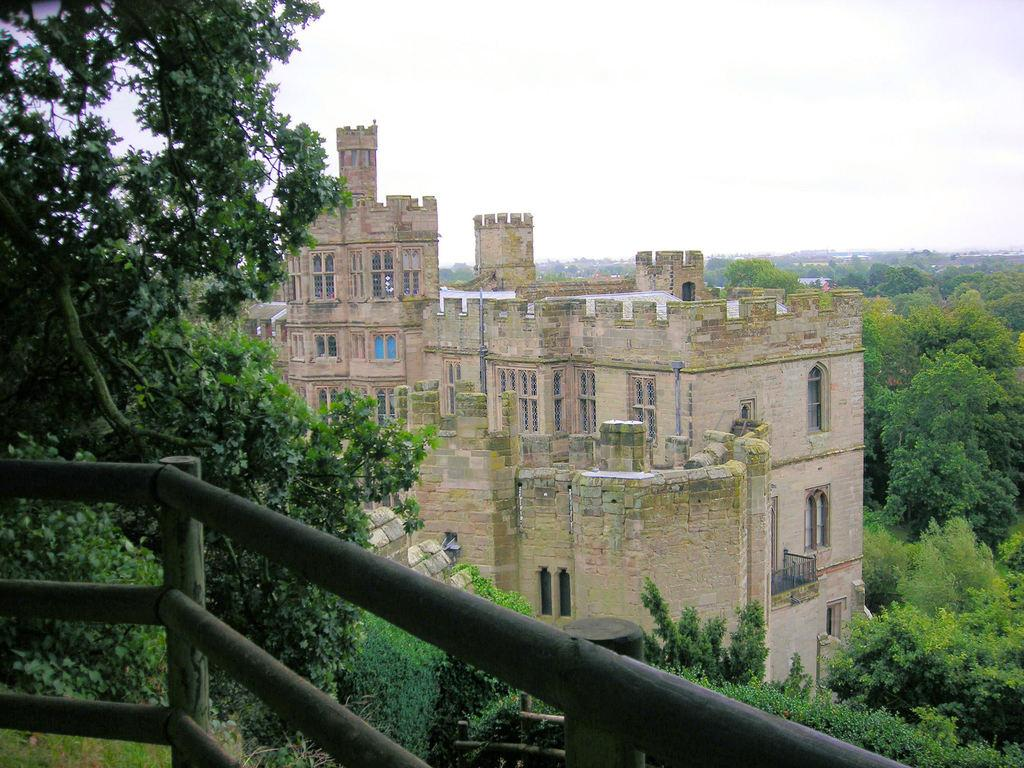What type of structures are visible in the image? There are buildings with windows in the image. What type of vegetation can be seen in the image? There are trees in the image. What type of barrier is present in the image? There is a fence in the image. What type of ground cover is present in the image? There is grass in the image. What is visible in the background of the image? The sky is visible in the background of the image. What type of fear is depicted in the image? There is no fear depicted in the image; it features buildings, trees, a fence, grass, and the sky. What type of car is parked in front of the building in the image? There is no car present in the image. 